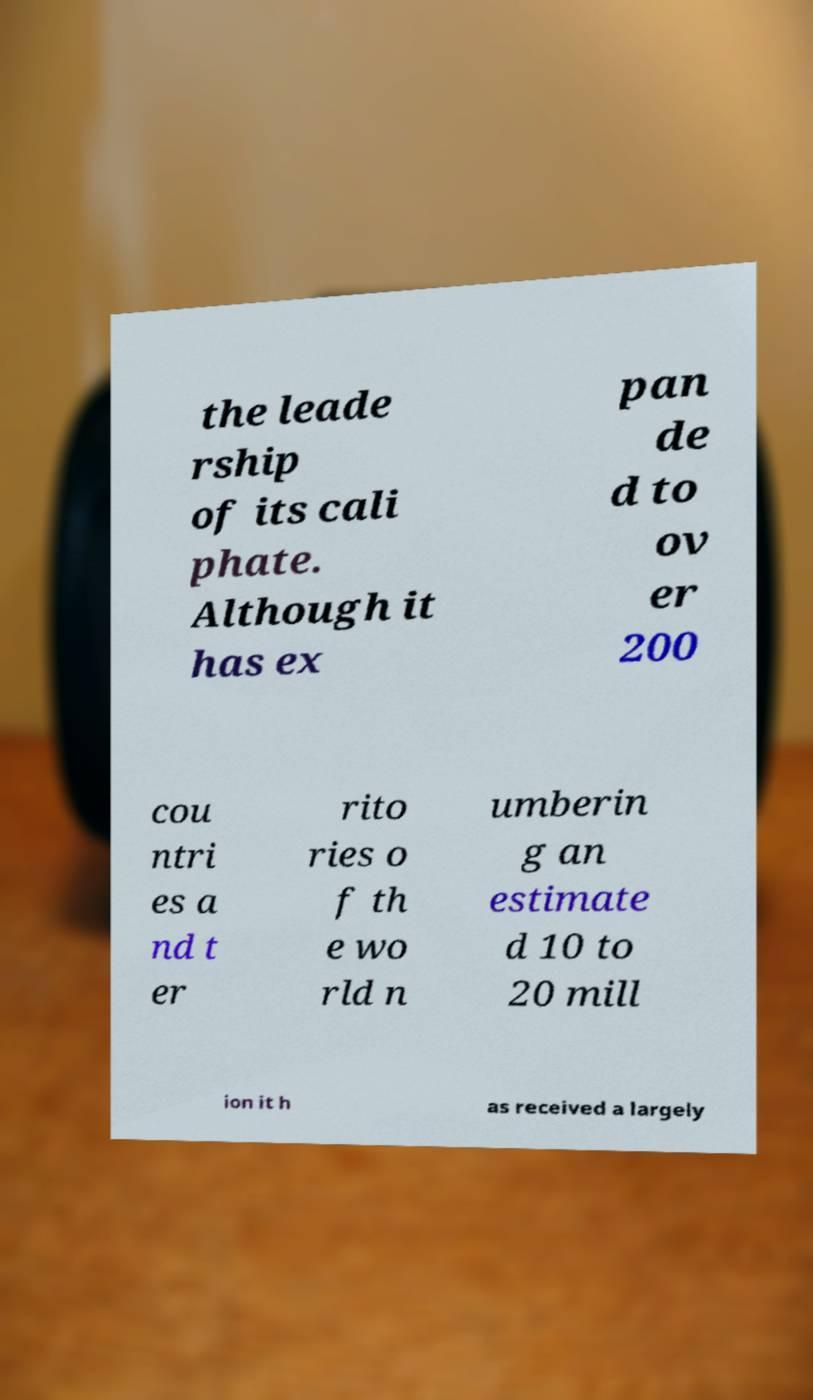Can you accurately transcribe the text from the provided image for me? the leade rship of its cali phate. Although it has ex pan de d to ov er 200 cou ntri es a nd t er rito ries o f th e wo rld n umberin g an estimate d 10 to 20 mill ion it h as received a largely 